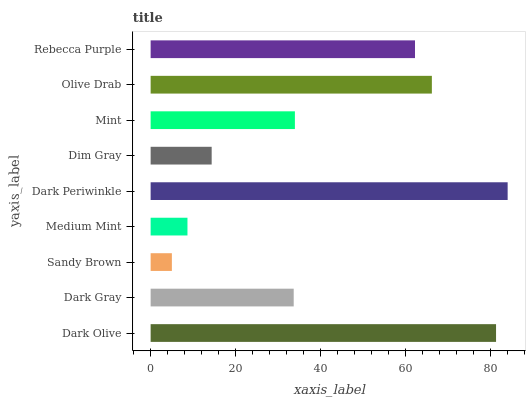Is Sandy Brown the minimum?
Answer yes or no. Yes. Is Dark Periwinkle the maximum?
Answer yes or no. Yes. Is Dark Gray the minimum?
Answer yes or no. No. Is Dark Gray the maximum?
Answer yes or no. No. Is Dark Olive greater than Dark Gray?
Answer yes or no. Yes. Is Dark Gray less than Dark Olive?
Answer yes or no. Yes. Is Dark Gray greater than Dark Olive?
Answer yes or no. No. Is Dark Olive less than Dark Gray?
Answer yes or no. No. Is Mint the high median?
Answer yes or no. Yes. Is Mint the low median?
Answer yes or no. Yes. Is Dark Gray the high median?
Answer yes or no. No. Is Medium Mint the low median?
Answer yes or no. No. 